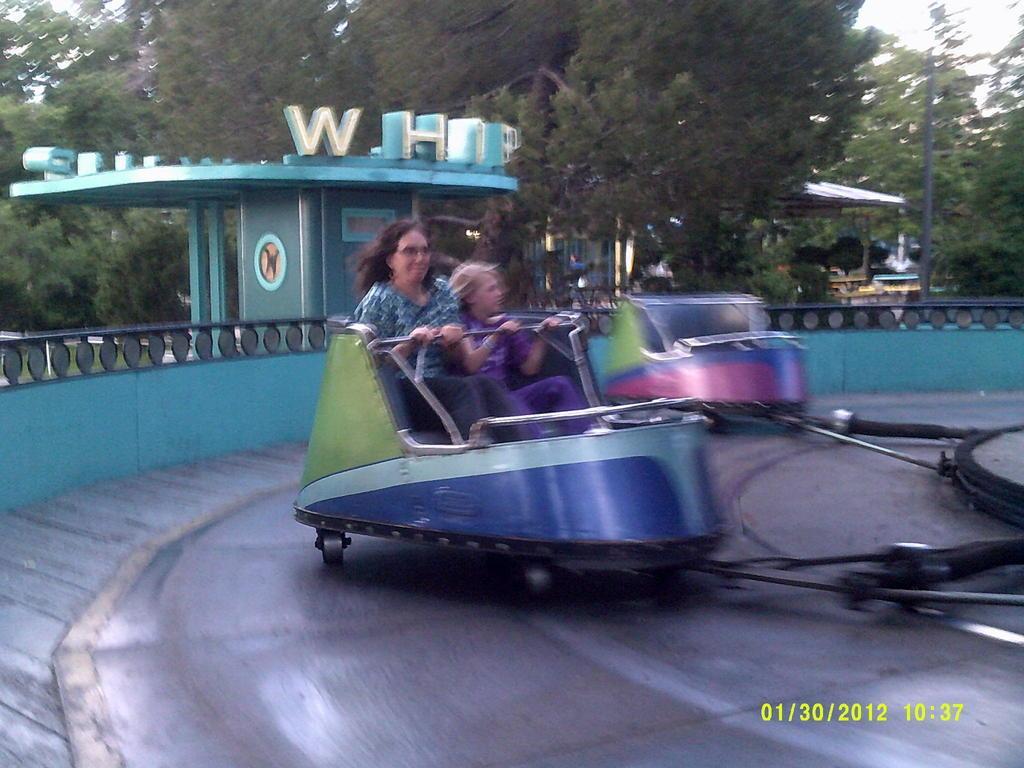In one or two sentences, can you explain what this image depicts? In this image two persons are sitting on roller coaster and multiple trees are in the background ,A electrical pole is seen in the image. 